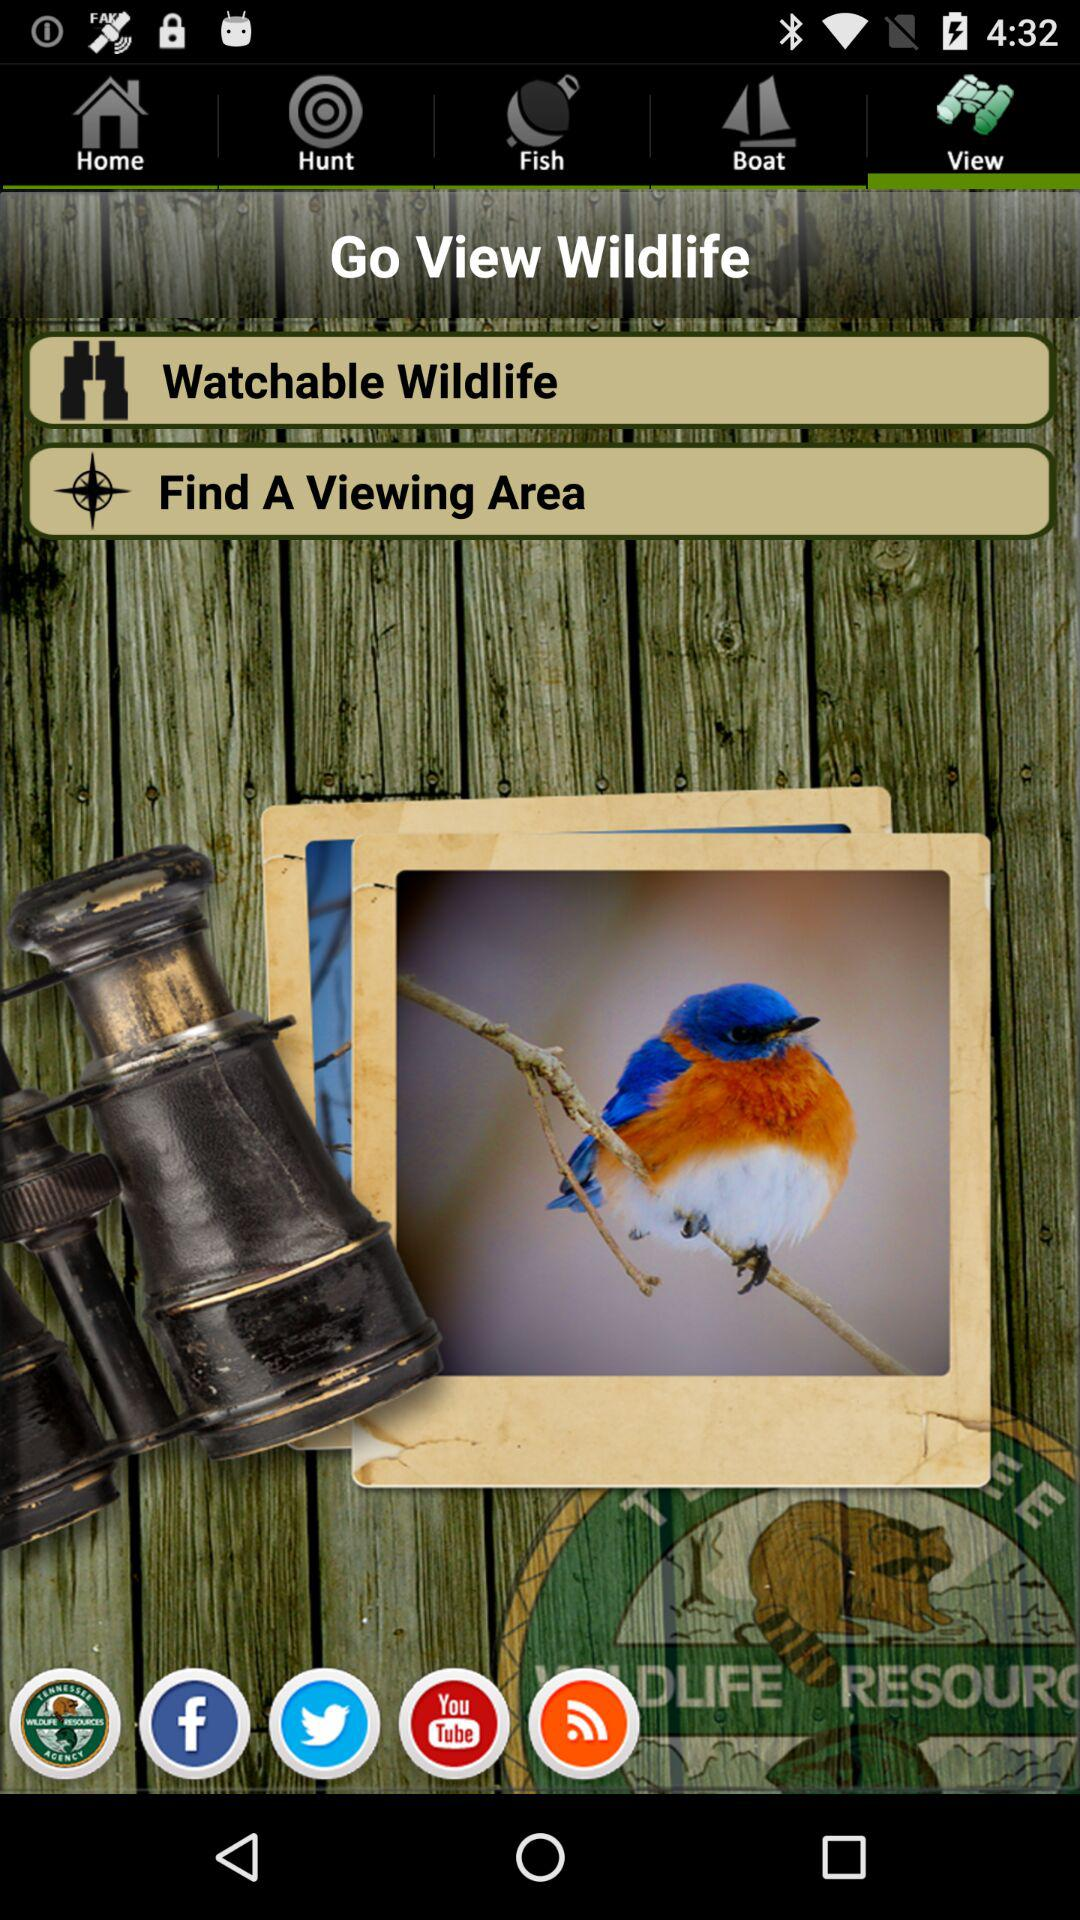What are the different sharing options?
When the provided information is insufficient, respond with <no answer>. <no answer> 